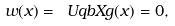Convert formula to latex. <formula><loc_0><loc_0><loc_500><loc_500>w ( x ) = \ U q b X g ( x ) = 0 ,</formula> 